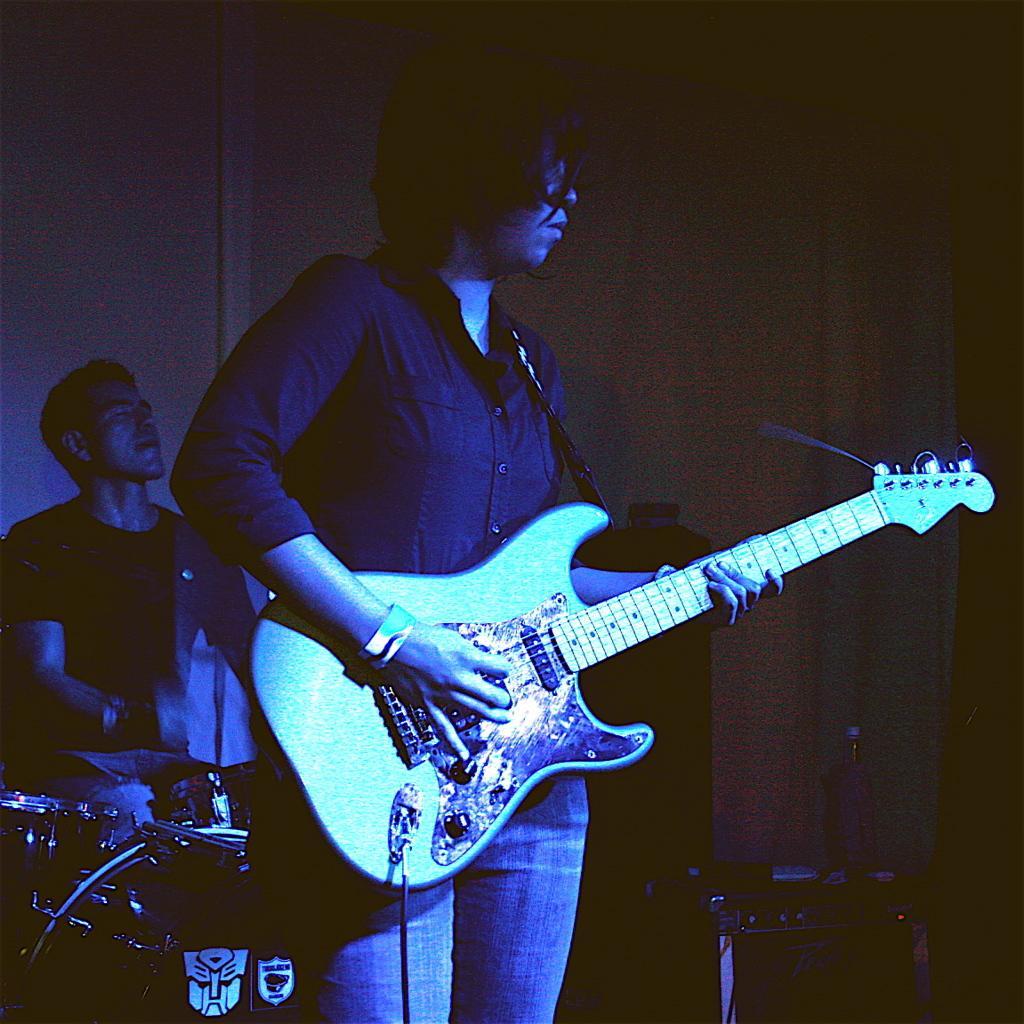Describe this image in one or two sentences. Here in the front we can see a person playing a guitar and behind him we can see a person playing drums 